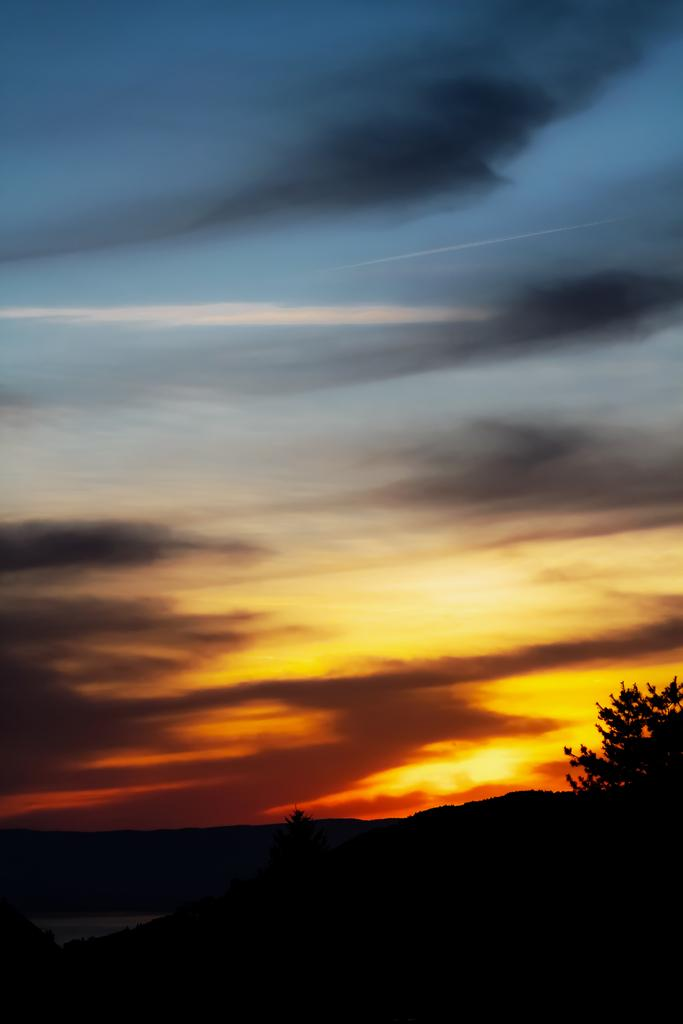What type of vegetation can be seen in the image? There are trees in the image. What part of the natural environment is visible in the image? The sky is visible in the image. What can be observed in the sky in the image? Clouds are present in the image. How would you describe the lighting in the image? The image appears to be slightly dark. How far away is the help that can be seen in the image? There is no help visible in the image; it only features trees, sky, clouds, and a slightly dark lighting. What type of suggestion can be made based on the image? The image does not provide any specific suggestions or recommendations, as it only shows trees, sky, clouds, and a slightly dark lighting. 